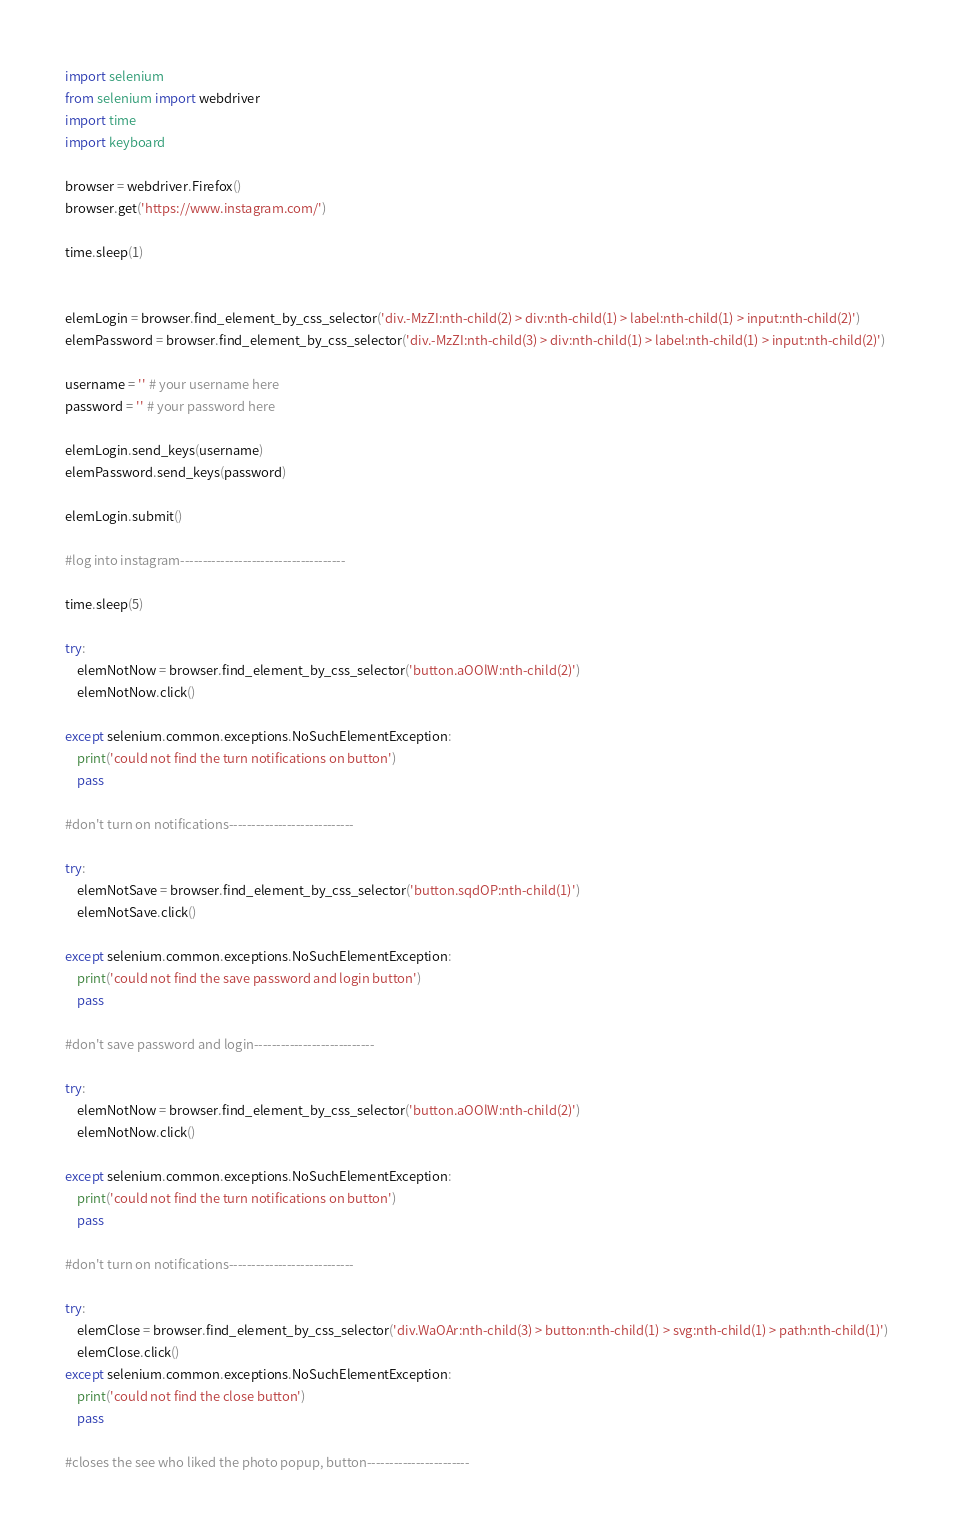<code> <loc_0><loc_0><loc_500><loc_500><_Python_>import selenium
from selenium import webdriver
import time
import keyboard

browser = webdriver.Firefox()
browser.get('https://www.instagram.com/')

time.sleep(1)


elemLogin = browser.find_element_by_css_selector('div.-MzZI:nth-child(2) > div:nth-child(1) > label:nth-child(1) > input:nth-child(2)')
elemPassword = browser.find_element_by_css_selector('div.-MzZI:nth-child(3) > div:nth-child(1) > label:nth-child(1) > input:nth-child(2)')

username = '' # your username here
password = '' # your password here

elemLogin.send_keys(username)
elemPassword.send_keys(password)

elemLogin.submit()

#log into instagram-------------------------------------

time.sleep(5)

try:
    elemNotNow = browser.find_element_by_css_selector('button.aOOlW:nth-child(2)')
    elemNotNow.click()

except selenium.common.exceptions.NoSuchElementException:
    print('could not find the turn notifications on button')
    pass

#don't turn on notifications----------------------------

try:
    elemNotSave = browser.find_element_by_css_selector('button.sqdOP:nth-child(1)')
    elemNotSave.click()

except selenium.common.exceptions.NoSuchElementException:
    print('could not find the save password and login button')
    pass

#don't save password and login---------------------------

try:
    elemNotNow = browser.find_element_by_css_selector('button.aOOlW:nth-child(2)')
    elemNotNow.click()

except selenium.common.exceptions.NoSuchElementException:
    print('could not find the turn notifications on button')
    pass

#don't turn on notifications----------------------------

try:
    elemClose = browser.find_element_by_css_selector('div.WaOAr:nth-child(3) > button:nth-child(1) > svg:nth-child(1) > path:nth-child(1)')
    elemClose.click()
except selenium.common.exceptions.NoSuchElementException: 
    print('could not find the close button')
    pass

#closes the see who liked the photo popup, button-----------------------
</code> 